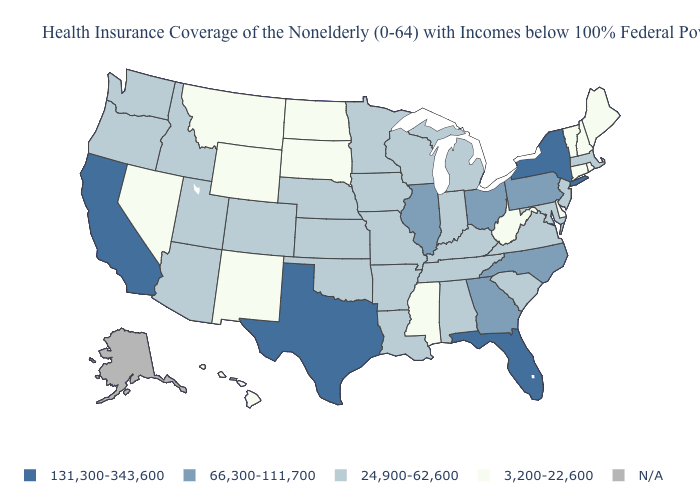Is the legend a continuous bar?
Give a very brief answer. No. Does the map have missing data?
Quick response, please. Yes. What is the value of New Jersey?
Write a very short answer. 24,900-62,600. What is the value of Kansas?
Write a very short answer. 24,900-62,600. Name the states that have a value in the range 66,300-111,700?
Quick response, please. Georgia, Illinois, North Carolina, Ohio, Pennsylvania. Does Oklahoma have the highest value in the South?
Keep it brief. No. What is the value of North Carolina?
Answer briefly. 66,300-111,700. Name the states that have a value in the range 66,300-111,700?
Give a very brief answer. Georgia, Illinois, North Carolina, Ohio, Pennsylvania. Which states hav the highest value in the MidWest?
Short answer required. Illinois, Ohio. Among the states that border Montana , does Idaho have the highest value?
Write a very short answer. Yes. Which states have the lowest value in the Northeast?
Give a very brief answer. Connecticut, Maine, New Hampshire, Rhode Island, Vermont. Which states have the highest value in the USA?
Quick response, please. California, Florida, New York, Texas. 